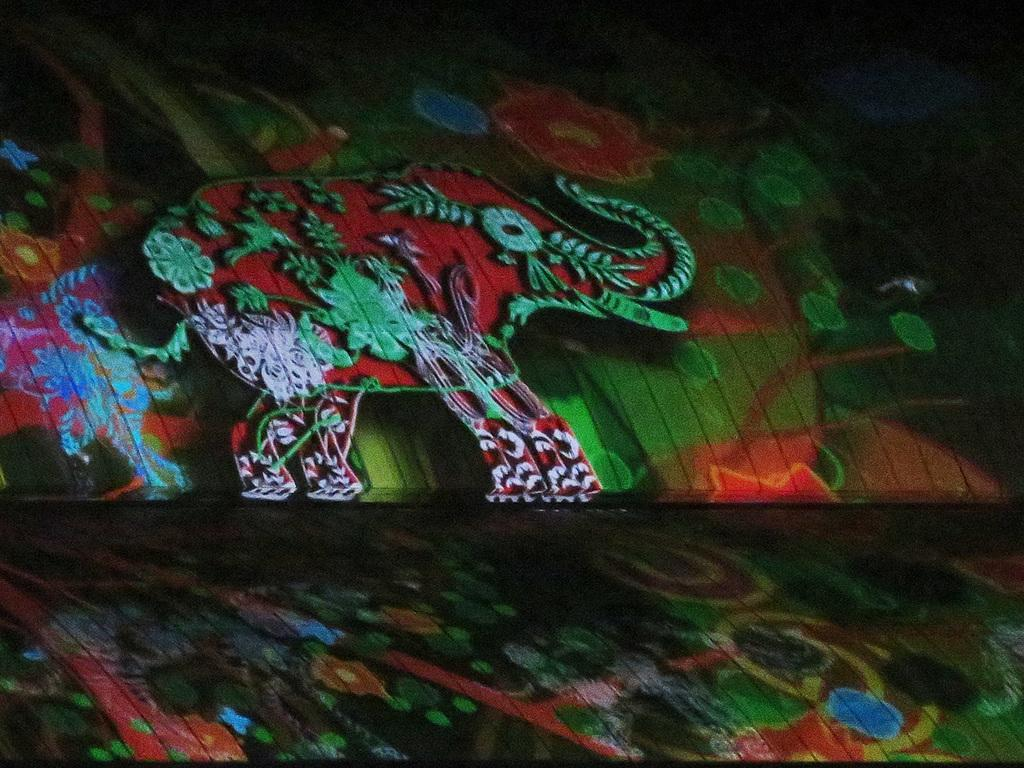What is the main subject of the image? There is a painting in the image. What is the painting on? The painting is on wooden objects. What is the painting depicting? The painting depicts an elephant. What other elements are present in the painting? The painting includes trees and other objects. What type of leaf can be seen in the painting? There is no leaf present in the painting; it depicts an elephant, trees, and other objects. What is the voice of the elephant in the painting? The painting is a static image and does not include any sounds or voices. 